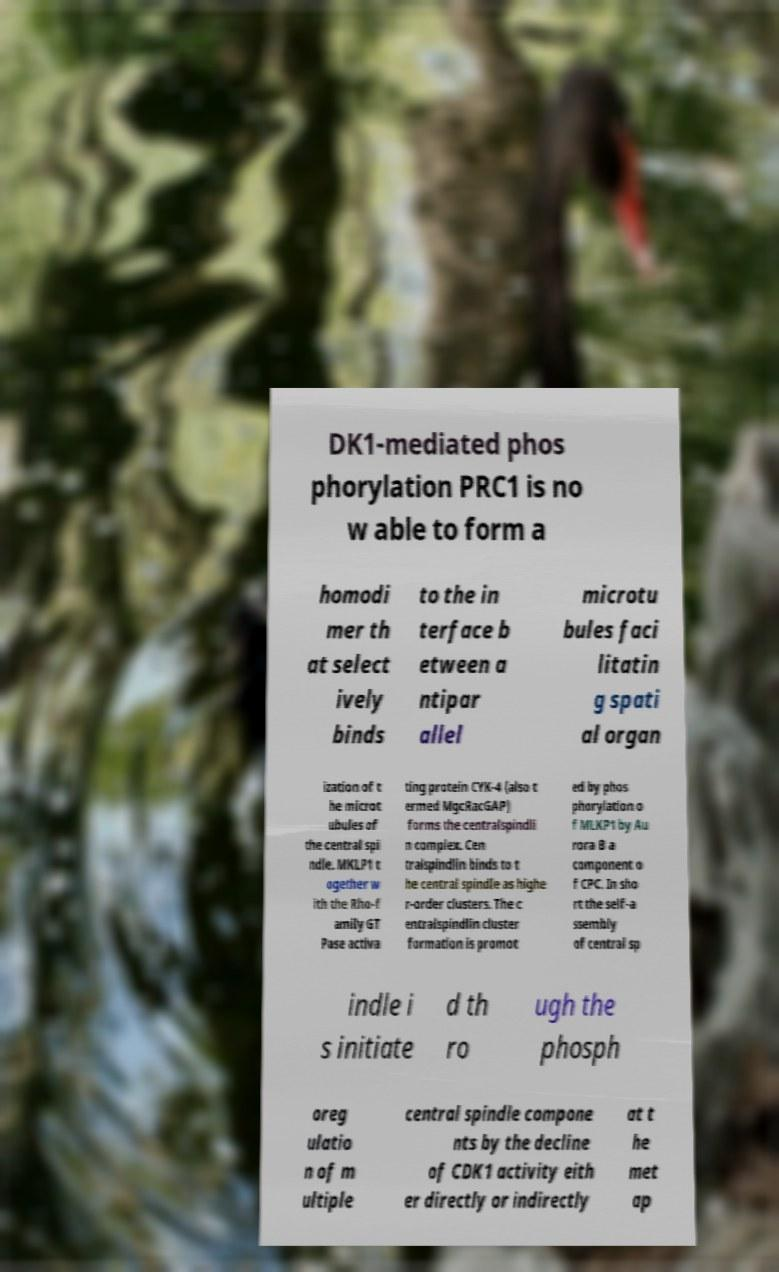I need the written content from this picture converted into text. Can you do that? DK1-mediated phos phorylation PRC1 is no w able to form a homodi mer th at select ively binds to the in terface b etween a ntipar allel microtu bules faci litatin g spati al organ ization of t he microt ubules of the central spi ndle. MKLP1 t ogether w ith the Rho-f amily GT Pase activa ting protein CYK-4 (also t ermed MgcRacGAP) forms the centralspindli n complex. Cen tralspindlin binds to t he central spindle as highe r-order clusters. The c entralspindlin cluster formation is promot ed by phos phorylation o f MLKP1 by Au rora B a component o f CPC. In sho rt the self-a ssembly of central sp indle i s initiate d th ro ugh the phosph oreg ulatio n of m ultiple central spindle compone nts by the decline of CDK1 activity eith er directly or indirectly at t he met ap 